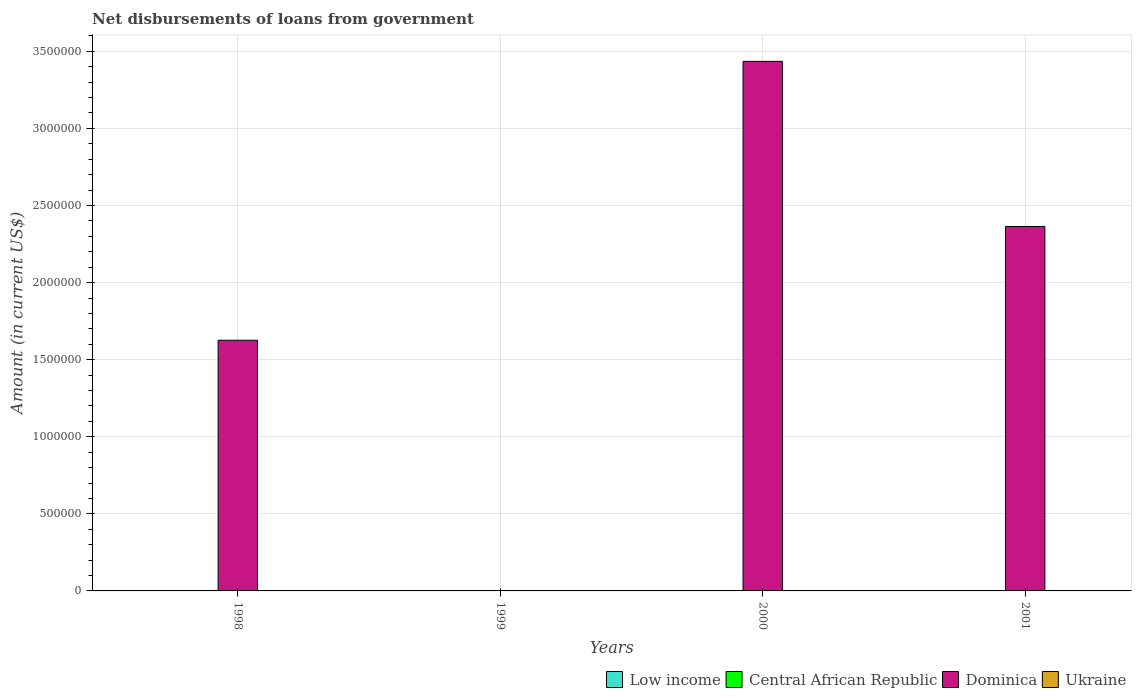Are the number of bars on each tick of the X-axis equal?
Your answer should be very brief. No. In how many cases, is the number of bars for a given year not equal to the number of legend labels?
Your answer should be compact. 4. Across all years, what is the minimum amount of loan disbursed from government in Ukraine?
Make the answer very short. 0. What is the difference between the amount of loan disbursed from government in Dominica in 1998 and that in 2001?
Offer a very short reply. -7.38e+05. What is the difference between the amount of loan disbursed from government in Central African Republic in 2000 and the amount of loan disbursed from government in Dominica in 1999?
Give a very brief answer. 0. What is the average amount of loan disbursed from government in Ukraine per year?
Provide a short and direct response. 0. What is the ratio of the amount of loan disbursed from government in Dominica in 1998 to that in 2000?
Your response must be concise. 0.47. What is the difference between the highest and the second highest amount of loan disbursed from government in Dominica?
Offer a very short reply. 1.07e+06. What is the difference between the highest and the lowest amount of loan disbursed from government in Dominica?
Your answer should be compact. 3.44e+06. Is it the case that in every year, the sum of the amount of loan disbursed from government in Dominica and amount of loan disbursed from government in Low income is greater than the amount of loan disbursed from government in Central African Republic?
Offer a very short reply. No. How many bars are there?
Your response must be concise. 3. Are all the bars in the graph horizontal?
Offer a very short reply. No. How many years are there in the graph?
Provide a succinct answer. 4. What is the difference between two consecutive major ticks on the Y-axis?
Keep it short and to the point. 5.00e+05. Does the graph contain any zero values?
Your response must be concise. Yes. Does the graph contain grids?
Offer a very short reply. Yes. How are the legend labels stacked?
Keep it short and to the point. Horizontal. What is the title of the graph?
Make the answer very short. Net disbursements of loans from government. What is the label or title of the X-axis?
Provide a succinct answer. Years. What is the label or title of the Y-axis?
Your answer should be compact. Amount (in current US$). What is the Amount (in current US$) in Dominica in 1998?
Provide a succinct answer. 1.63e+06. What is the Amount (in current US$) of Low income in 1999?
Make the answer very short. 0. What is the Amount (in current US$) of Ukraine in 1999?
Your answer should be compact. 0. What is the Amount (in current US$) in Dominica in 2000?
Your answer should be compact. 3.44e+06. What is the Amount (in current US$) in Dominica in 2001?
Provide a short and direct response. 2.36e+06. What is the Amount (in current US$) of Ukraine in 2001?
Offer a very short reply. 0. Across all years, what is the maximum Amount (in current US$) of Dominica?
Ensure brevity in your answer.  3.44e+06. What is the total Amount (in current US$) in Low income in the graph?
Offer a very short reply. 0. What is the total Amount (in current US$) in Central African Republic in the graph?
Your response must be concise. 0. What is the total Amount (in current US$) in Dominica in the graph?
Offer a very short reply. 7.42e+06. What is the difference between the Amount (in current US$) in Dominica in 1998 and that in 2000?
Keep it short and to the point. -1.81e+06. What is the difference between the Amount (in current US$) of Dominica in 1998 and that in 2001?
Your answer should be very brief. -7.38e+05. What is the difference between the Amount (in current US$) in Dominica in 2000 and that in 2001?
Your answer should be compact. 1.07e+06. What is the average Amount (in current US$) of Dominica per year?
Your answer should be compact. 1.86e+06. What is the ratio of the Amount (in current US$) of Dominica in 1998 to that in 2000?
Offer a terse response. 0.47. What is the ratio of the Amount (in current US$) in Dominica in 1998 to that in 2001?
Ensure brevity in your answer.  0.69. What is the ratio of the Amount (in current US$) in Dominica in 2000 to that in 2001?
Give a very brief answer. 1.45. What is the difference between the highest and the second highest Amount (in current US$) in Dominica?
Provide a succinct answer. 1.07e+06. What is the difference between the highest and the lowest Amount (in current US$) in Dominica?
Offer a terse response. 3.44e+06. 